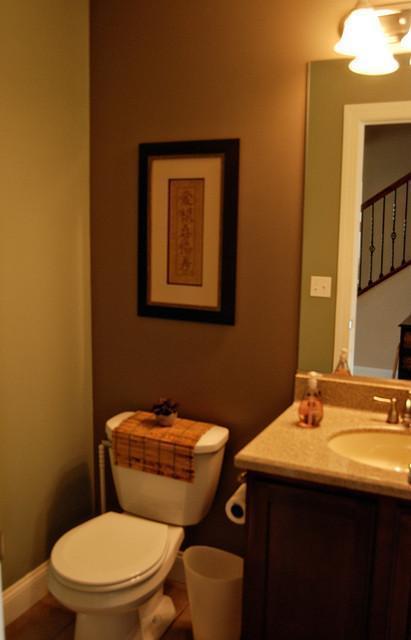How many things can a person plug in?
Give a very brief answer. 0. 